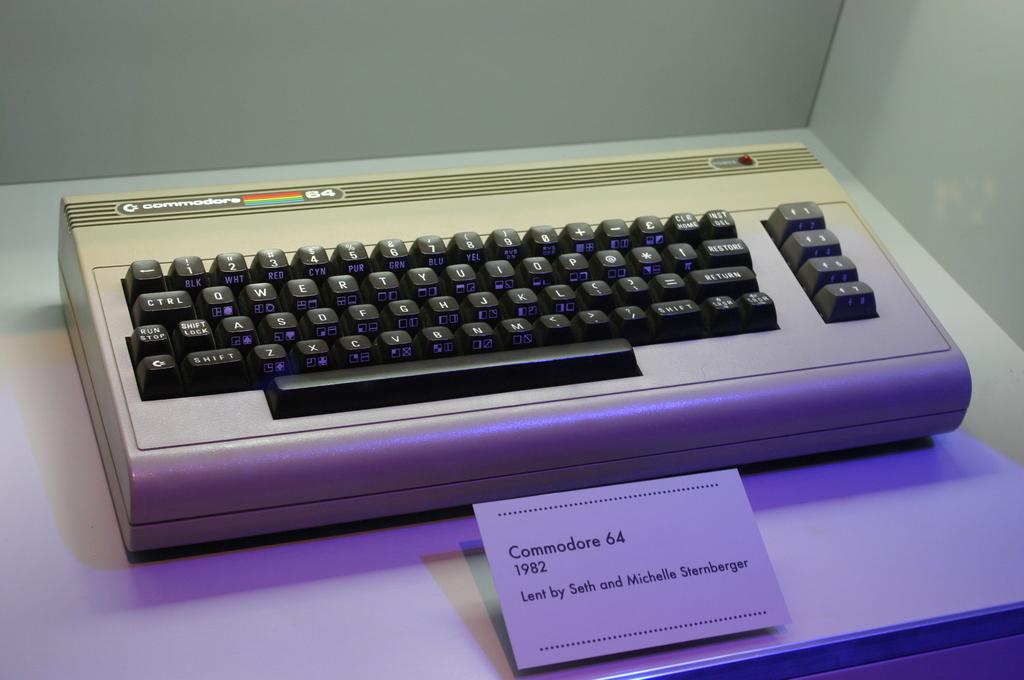Provide a one-sentence caption for the provided image. A display featuring a keyboard called the Commodore that was lent to the display by a couple named Seth and Michelle Sternberger. 